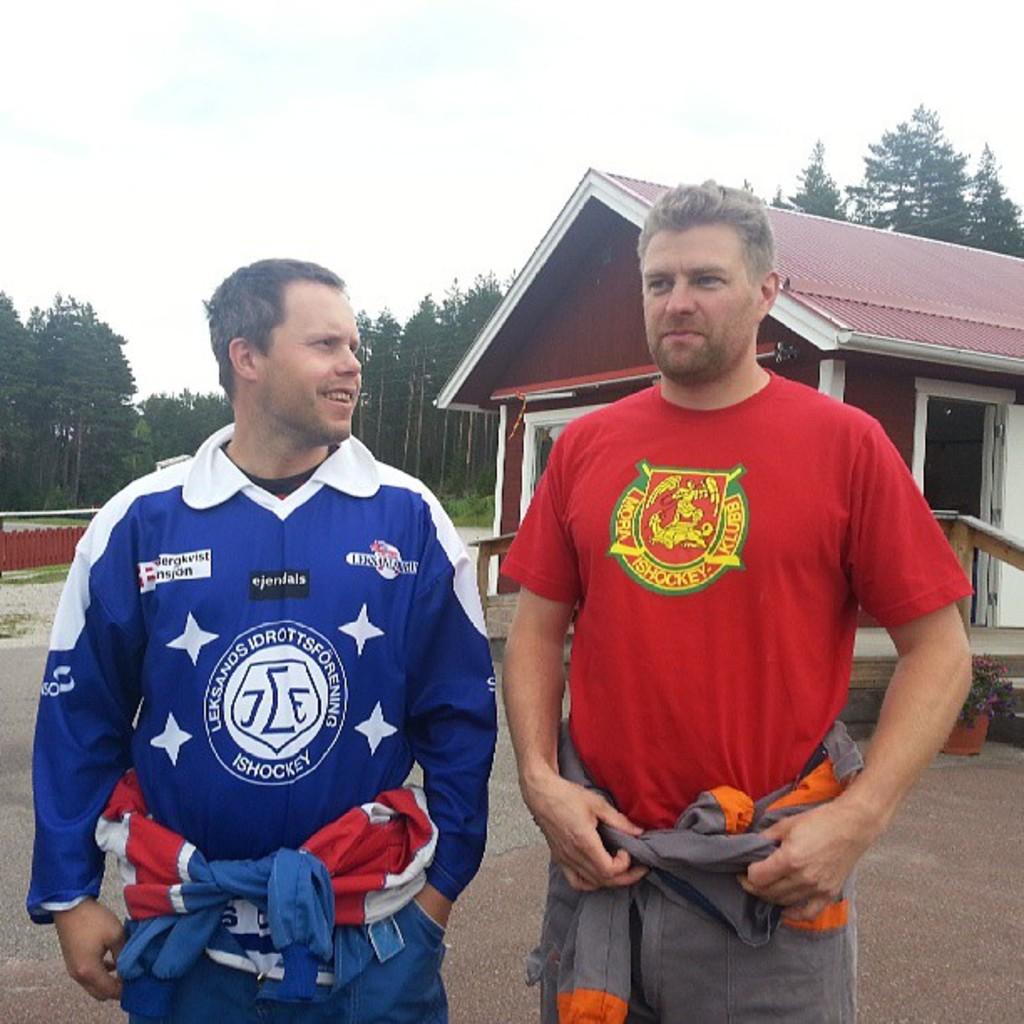What is the name of the red team?
Your response must be concise. Mora ishockey klubb. 